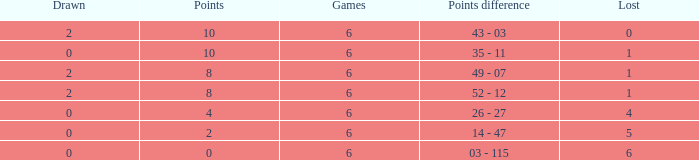What was the highest points where there were less than 2 drawn and the games were less than 6? None. 